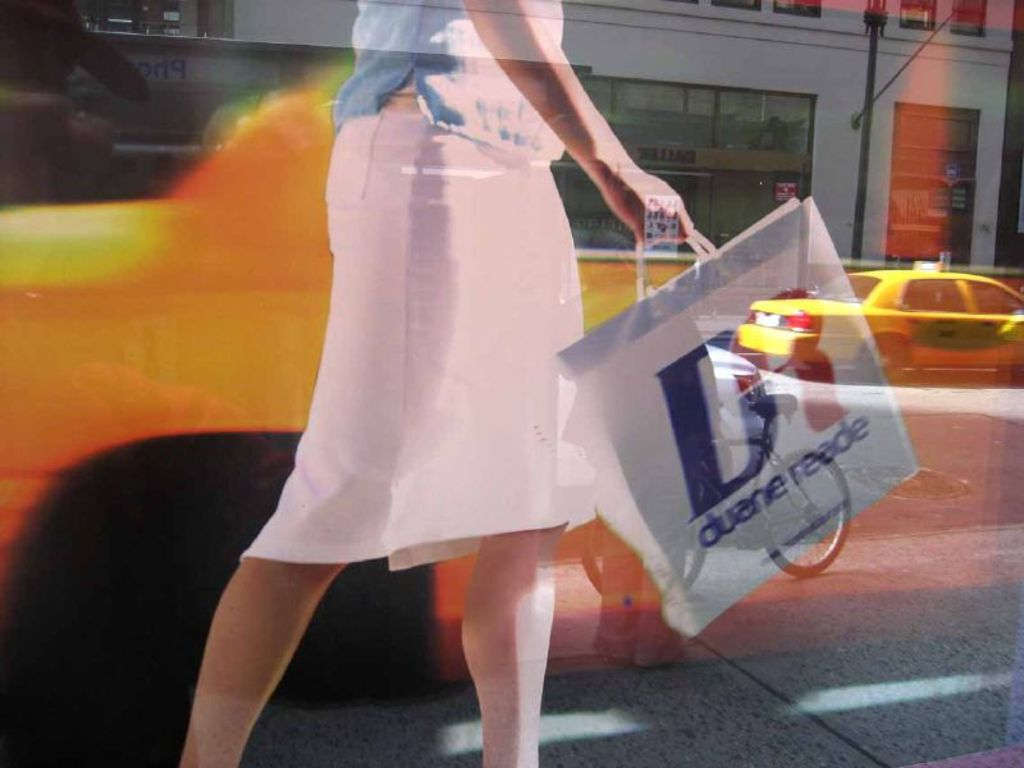Provide a one-sentence caption for the provided image. A woman in a flowing pink skirt briskly strides through a bustling city street, swinging a 'Duane Reade' shopping bag that catches the light and movement around her. 